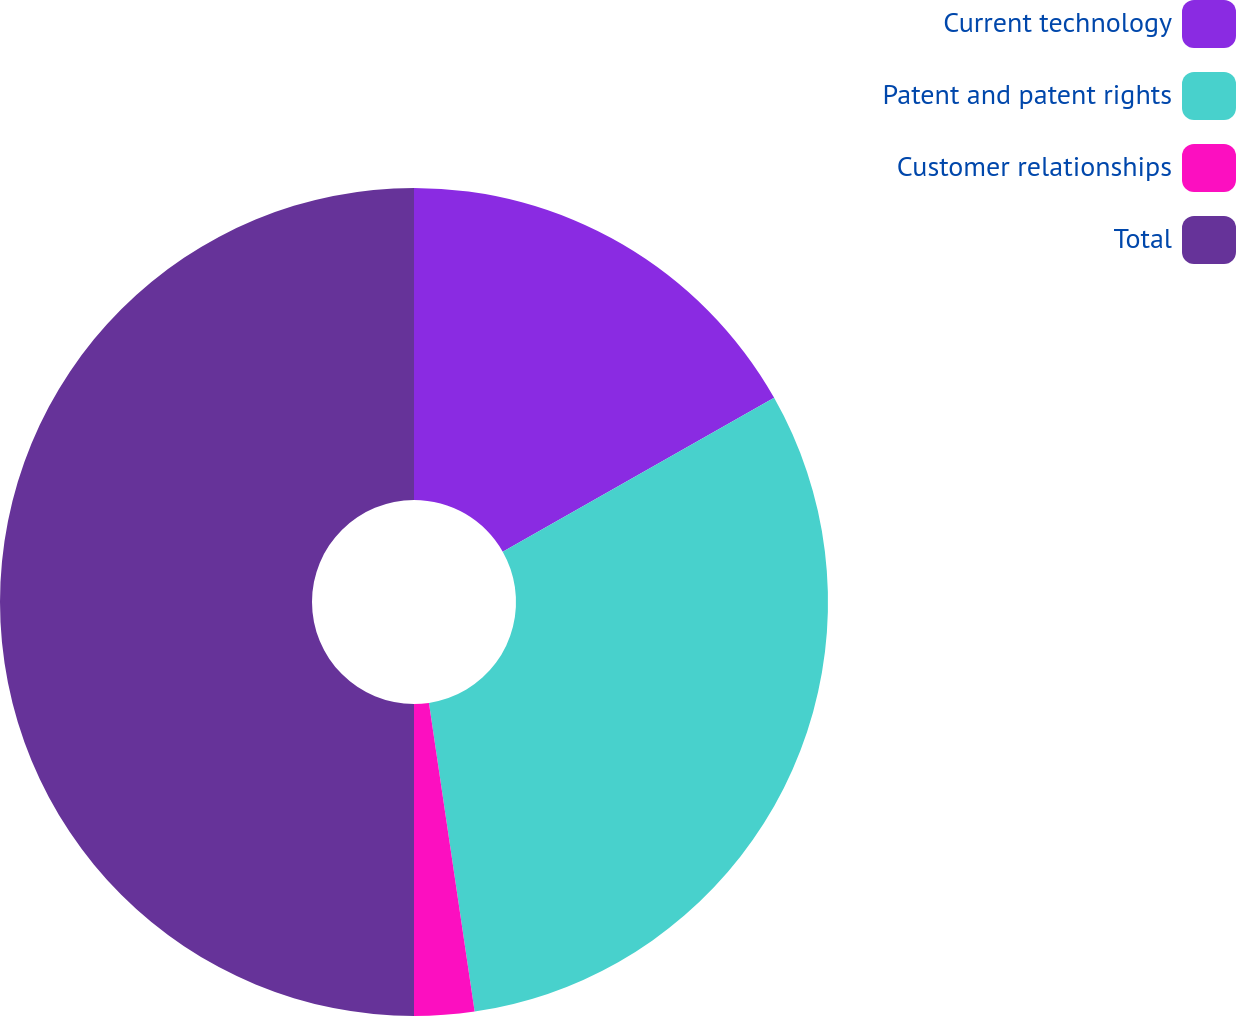<chart> <loc_0><loc_0><loc_500><loc_500><pie_chart><fcel>Current technology<fcel>Patent and patent rights<fcel>Customer relationships<fcel>Total<nl><fcel>16.79%<fcel>30.87%<fcel>2.34%<fcel>50.0%<nl></chart> 